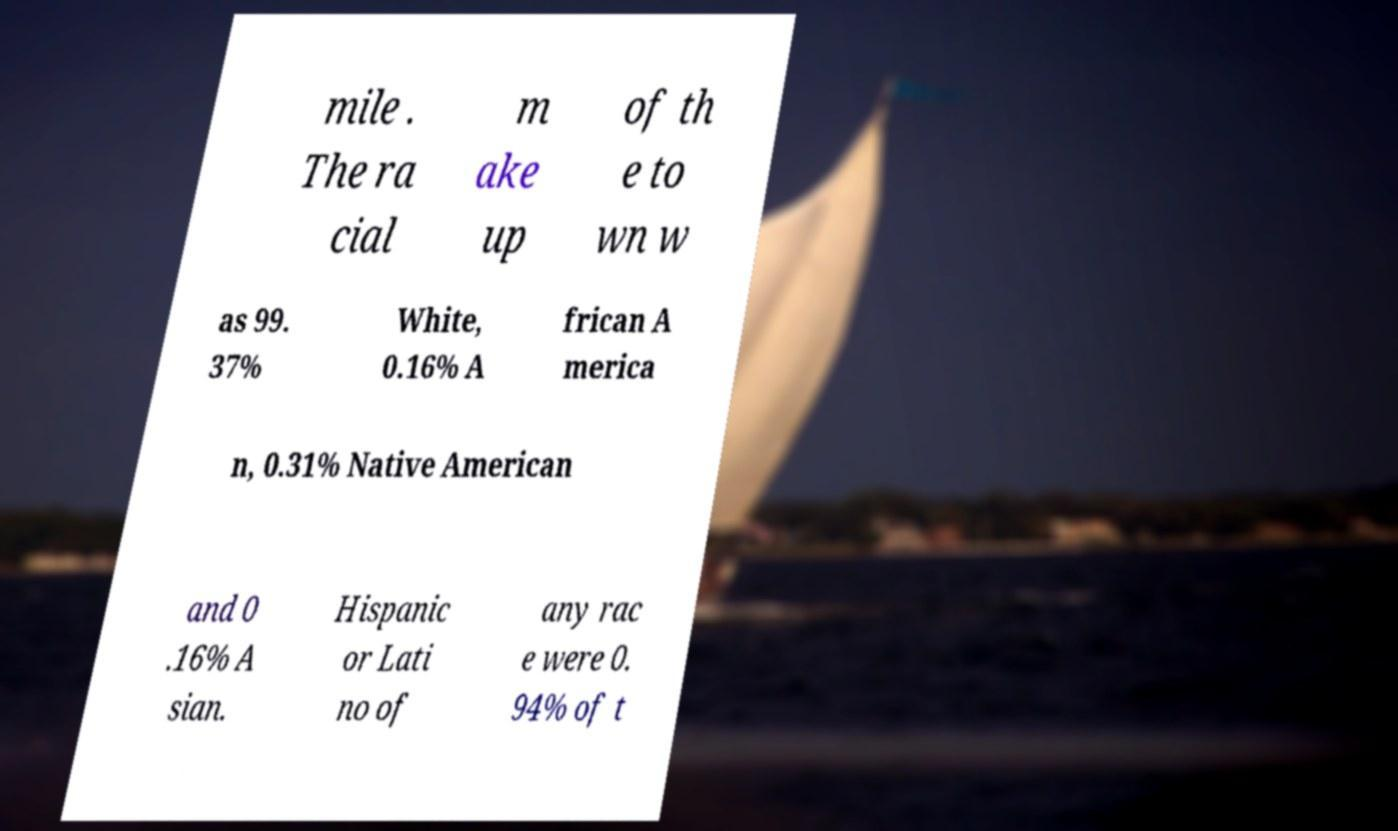Could you assist in decoding the text presented in this image and type it out clearly? mile . The ra cial m ake up of th e to wn w as 99. 37% White, 0.16% A frican A merica n, 0.31% Native American and 0 .16% A sian. Hispanic or Lati no of any rac e were 0. 94% of t 